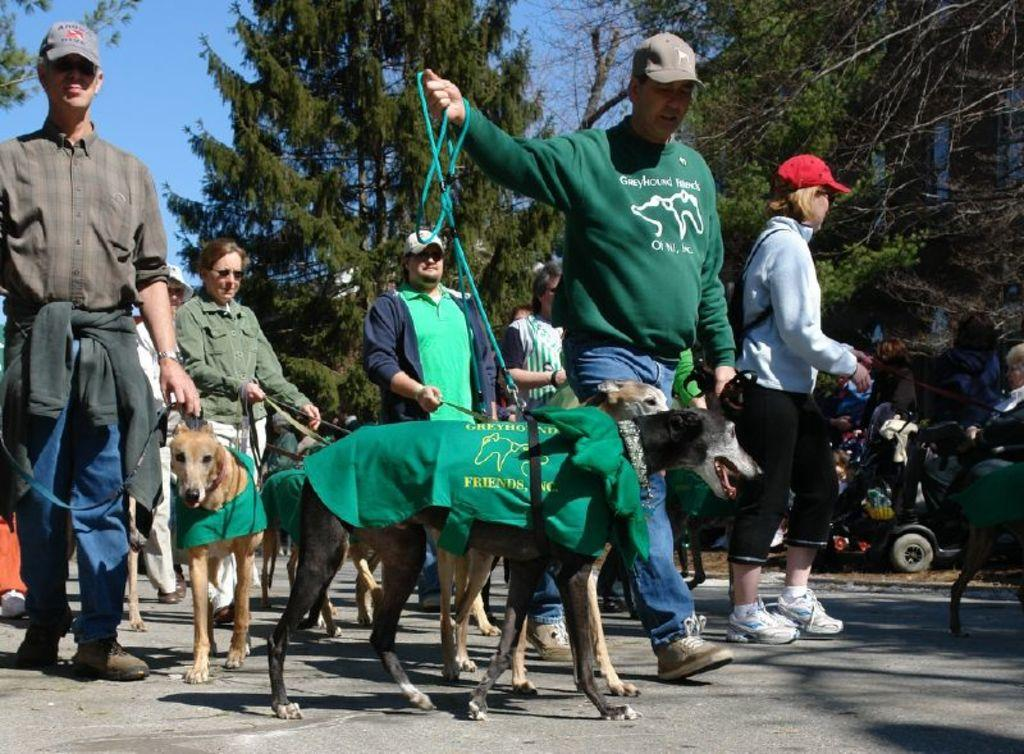How many people are in the image? There are persons in the image, but the exact number cannot be determined from the provided facts. What type of natural vegetation is present in the image? There are trees in the image. What animals can be seen in the middle of the image? There are dogs in the middle of the image. What type of wren is perched on the person's shoulder in the image? There is no wren present in the image; only persons, trees, and dogs are mentioned. What type of machine is being operated by the persons in the image? There is no machine present in the image; the focus is on the persons, trees, and dogs. 